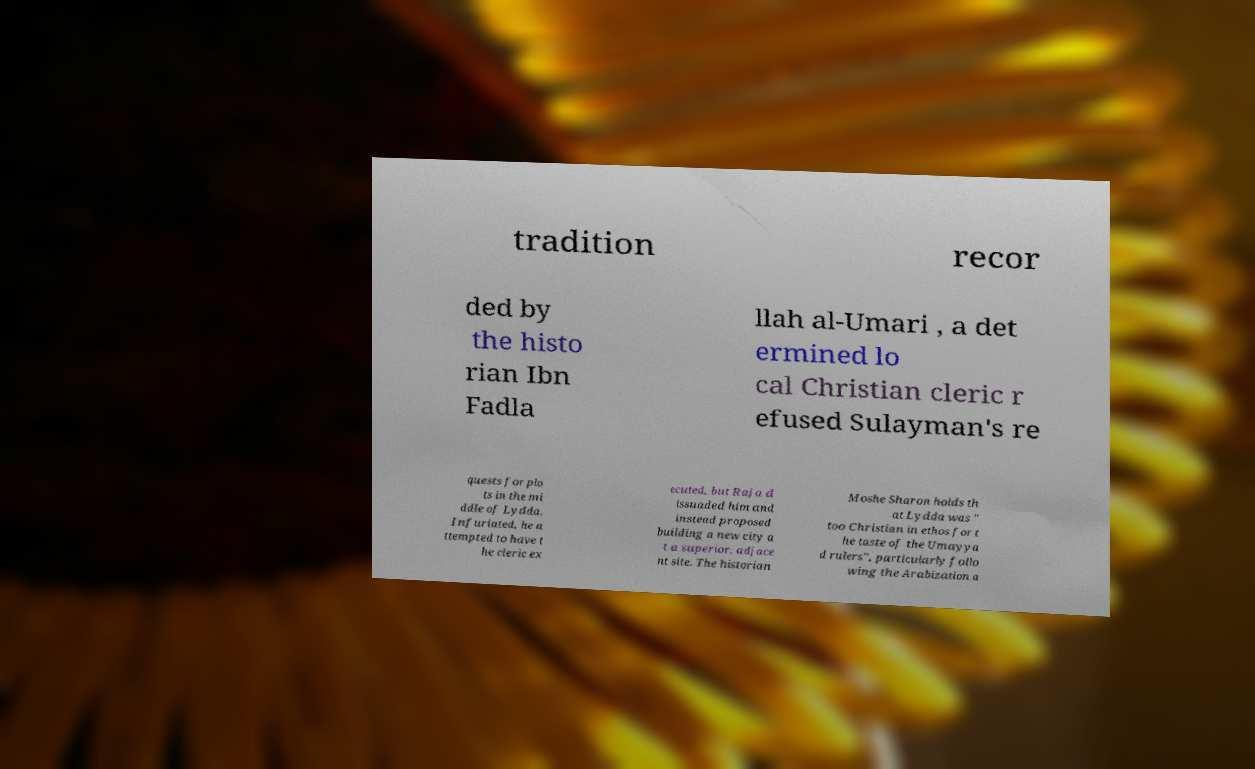Can you accurately transcribe the text from the provided image for me? tradition recor ded by the histo rian Ibn Fadla llah al-Umari , a det ermined lo cal Christian cleric r efused Sulayman's re quests for plo ts in the mi ddle of Lydda. Infuriated, he a ttempted to have t he cleric ex ecuted, but Raja d issuaded him and instead proposed building a new city a t a superior, adjace nt site. The historian Moshe Sharon holds th at Lydda was " too Christian in ethos for t he taste of the Umayya d rulers", particularly follo wing the Arabization a 